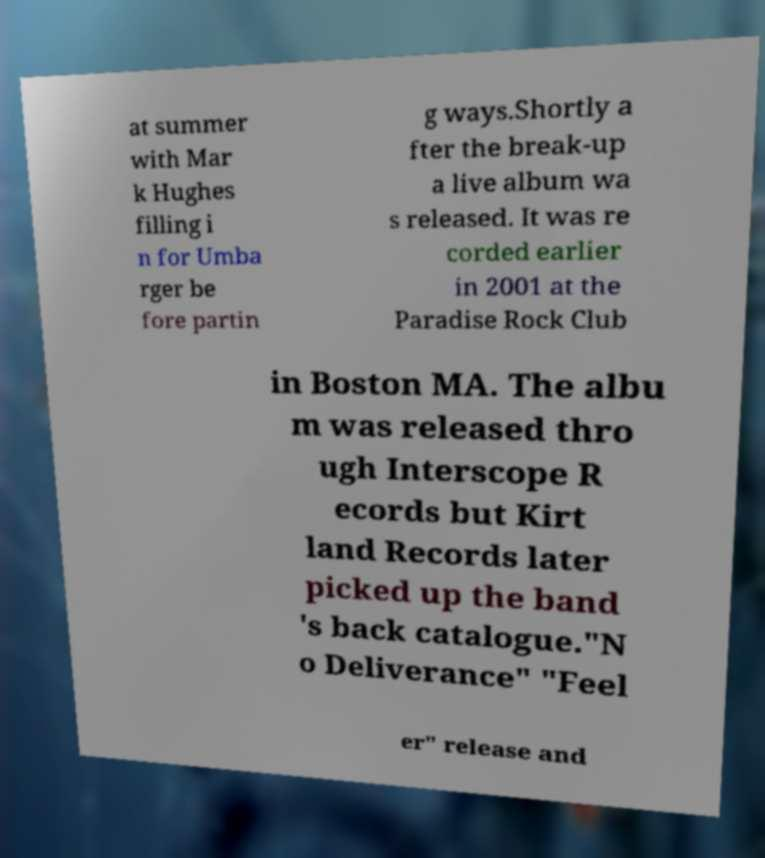Please read and relay the text visible in this image. What does it say? at summer with Mar k Hughes filling i n for Umba rger be fore partin g ways.Shortly a fter the break-up a live album wa s released. It was re corded earlier in 2001 at the Paradise Rock Club in Boston MA. The albu m was released thro ugh Interscope R ecords but Kirt land Records later picked up the band 's back catalogue."N o Deliverance" "Feel er" release and 